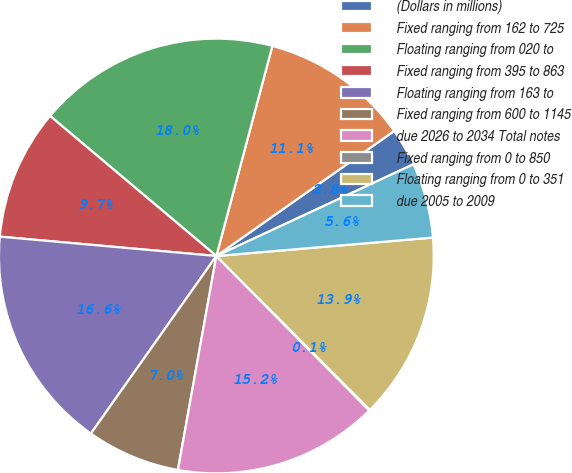Convert chart to OTSL. <chart><loc_0><loc_0><loc_500><loc_500><pie_chart><fcel>(Dollars in millions)<fcel>Fixed ranging from 162 to 725<fcel>Floating ranging from 020 to<fcel>Fixed ranging from 395 to 863<fcel>Floating ranging from 163 to<fcel>Fixed ranging from 600 to 1145<fcel>due 2026 to 2034 Total notes<fcel>Fixed ranging from 0 to 850<fcel>Floating ranging from 0 to 351<fcel>due 2005 to 2009<nl><fcel>2.82%<fcel>11.1%<fcel>18.01%<fcel>9.72%<fcel>16.63%<fcel>6.96%<fcel>15.25%<fcel>0.06%<fcel>13.87%<fcel>5.58%<nl></chart> 